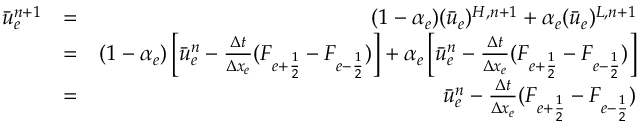<formula> <loc_0><loc_0><loc_500><loc_500>\begin{array} { r l r } { \bar { u } _ { e } ^ { n + 1 } } & { = } & { ( 1 - \alpha _ { e } ) ( \bar { u } _ { e } ) ^ { H , n + 1 } + \alpha _ { e } ( \bar { u } _ { e } ) ^ { L , n + 1 } } \\ & { = } & { ( 1 - \alpha _ { e } ) \left [ \bar { u } _ { e } ^ { n } - \frac { \Delta t } { \Delta x _ { e } } ( F _ { e + \frac { 1 } { 2 } } - F _ { e - \frac { 1 } { 2 } } ) \right ] + \alpha _ { e } \left [ \bar { u } _ { e } ^ { n } - \frac { \Delta t } { \Delta x _ { e } } ( F _ { e + \frac { 1 } { 2 } } - F _ { e - \frac { 1 } { 2 } } ) \right ] } \\ & { = } & { \bar { u } _ { e } ^ { n } - \frac { \Delta t } { \Delta x _ { e } } ( F _ { e + \frac { 1 } { 2 } } - F _ { e - \frac { 1 } { 2 } } ) } \end{array}</formula> 